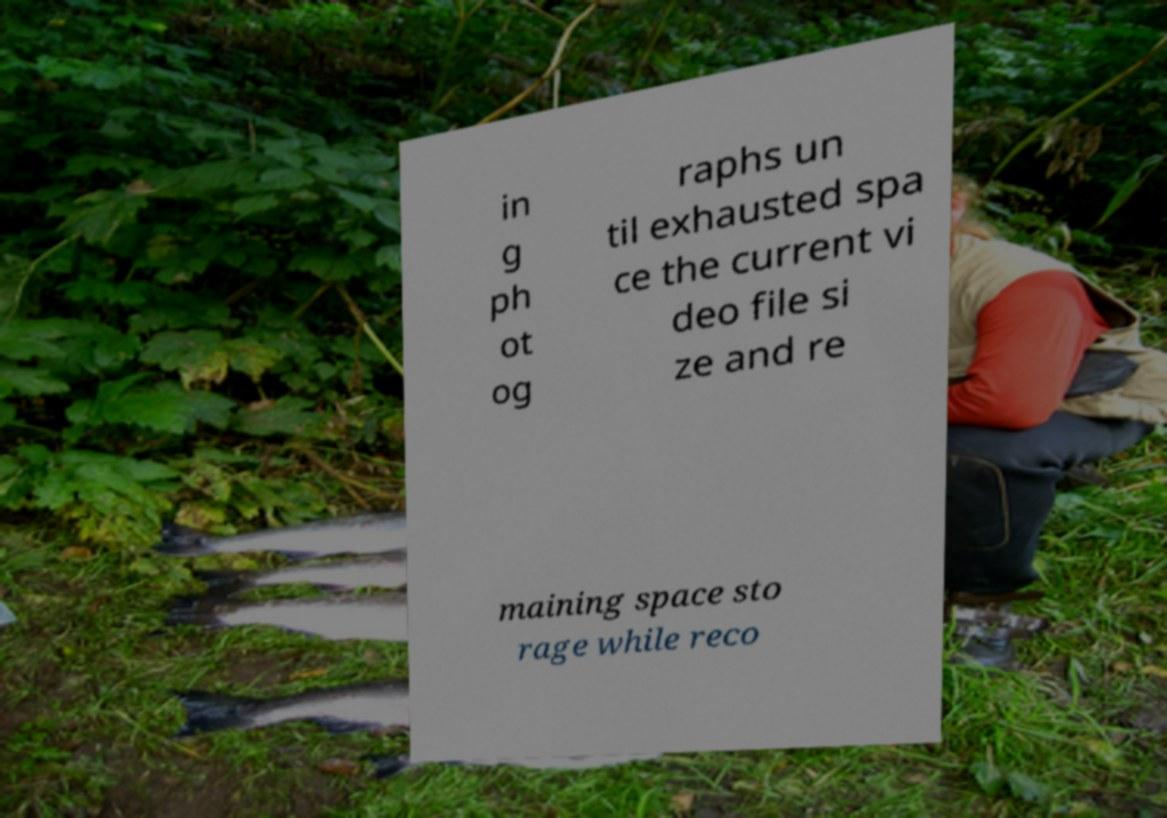Could you assist in decoding the text presented in this image and type it out clearly? in g ph ot og raphs un til exhausted spa ce the current vi deo file si ze and re maining space sto rage while reco 